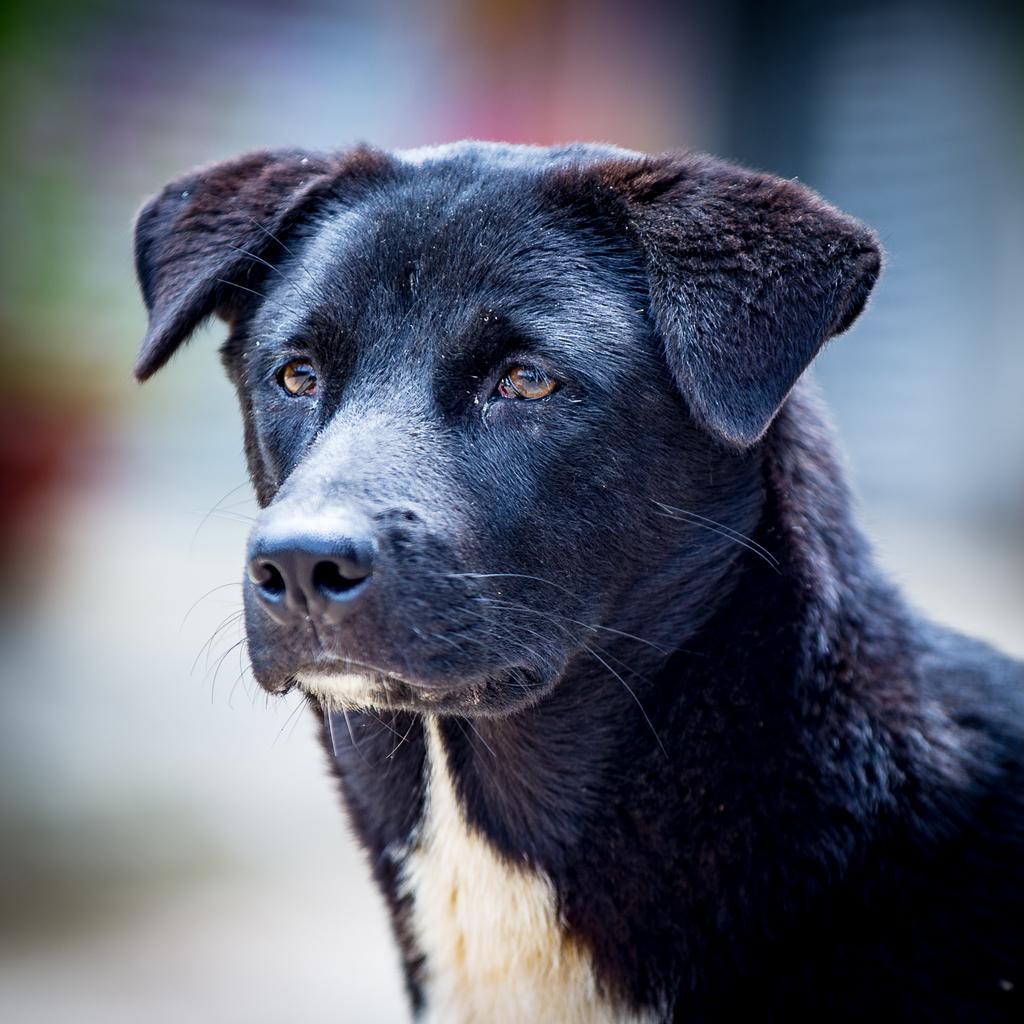Describe this image in one or two sentences. In this image there is a dog, in the background it is blurred. 